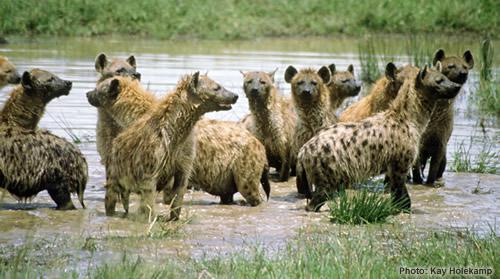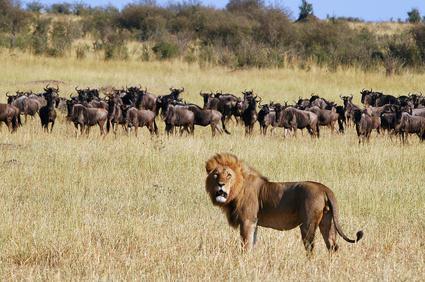The first image is the image on the left, the second image is the image on the right. Examine the images to the left and right. Is the description "There are more than eight hyenas." accurate? Answer yes or no. Yes. 